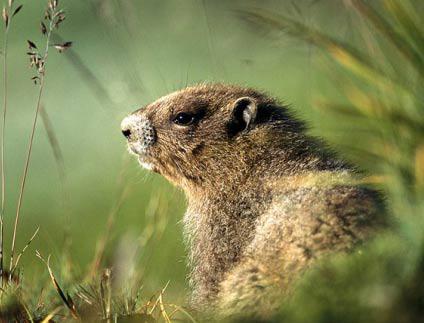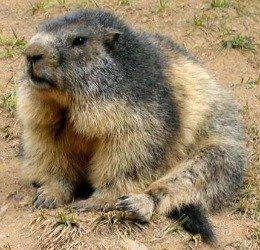The first image is the image on the left, the second image is the image on the right. Considering the images on both sides, is "There are only two animals and at least one appears to be eating something." valid? Answer yes or no. No. The first image is the image on the left, the second image is the image on the right. Assess this claim about the two images: "At least one animal is eating.". Correct or not? Answer yes or no. No. 